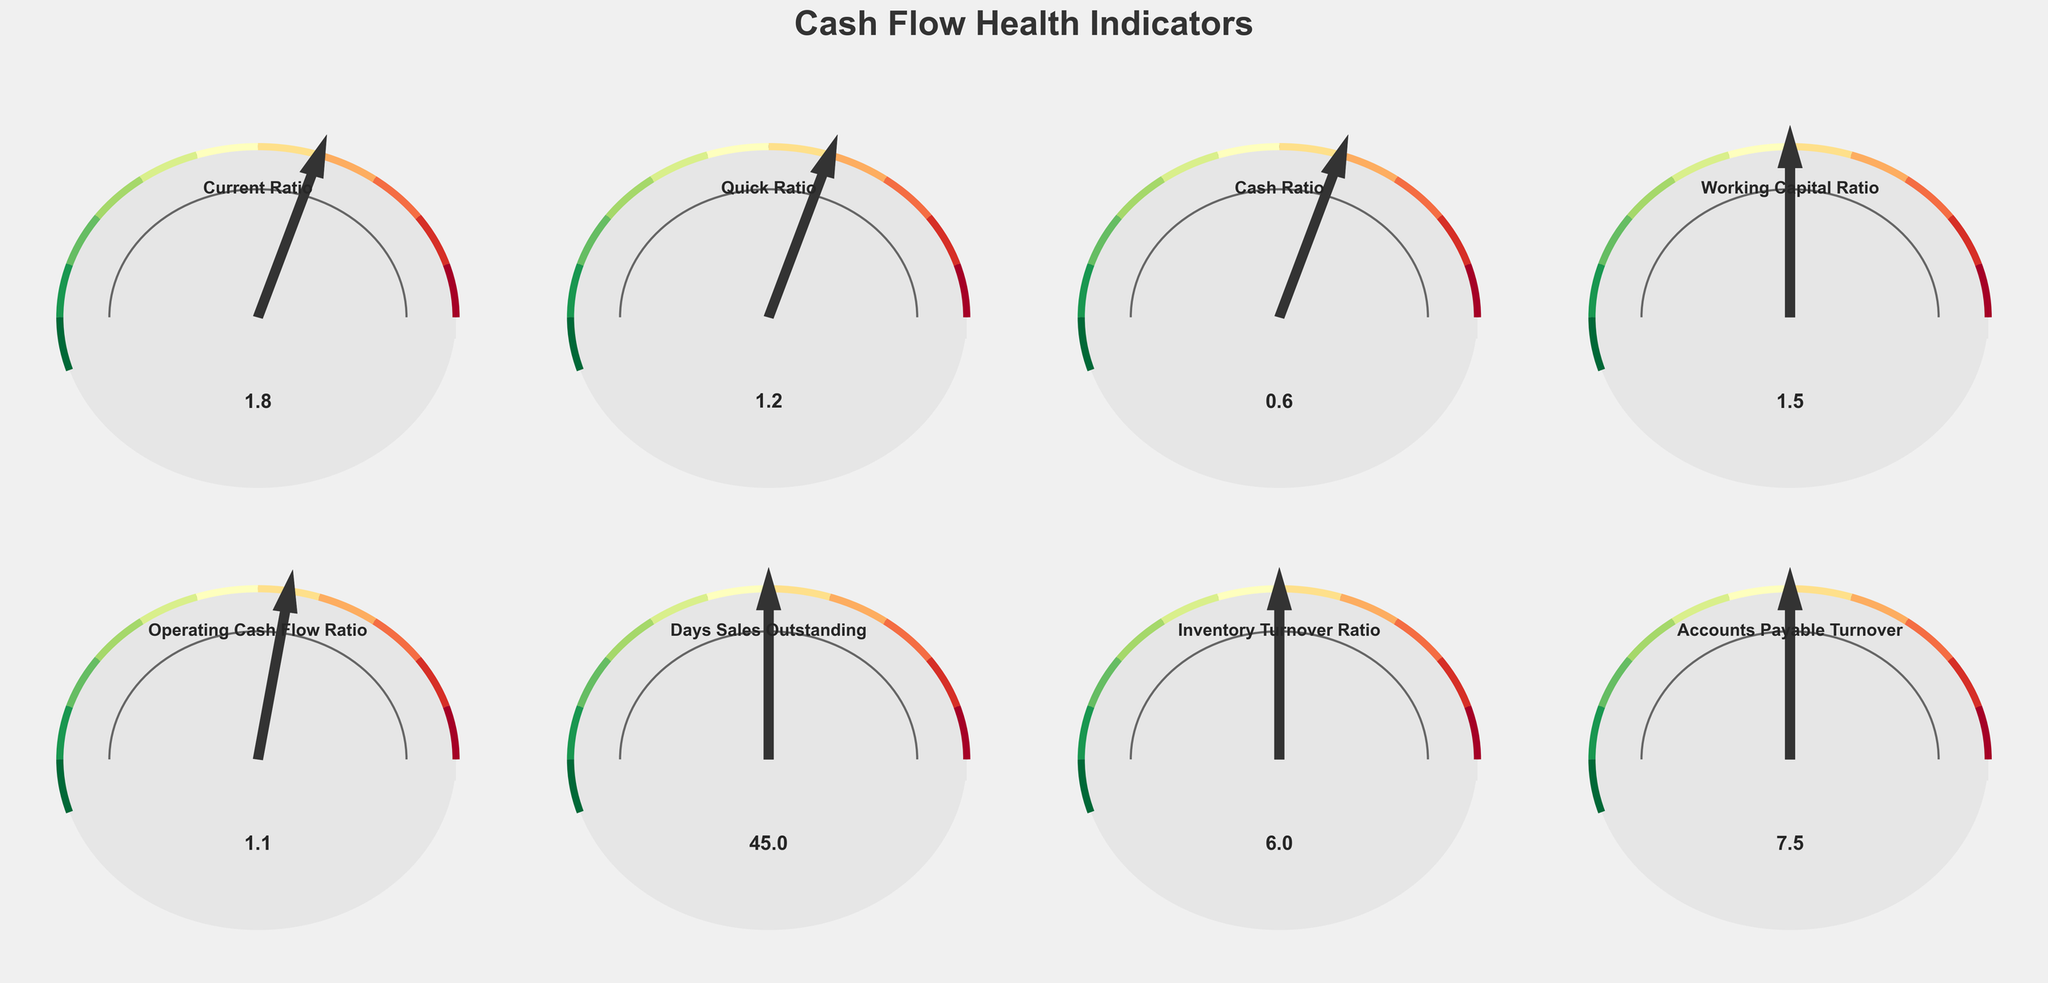What is the value of the Current Ratio? The Current Ratio is displayed on its respective gauge and marked as 1.8.
Answer: 1.8 What is the highest value displayed in any of the gauges? The Days Sales Outstanding gauge shows the highest value, marked at 45 days.
Answer: 45 Which ratio has the smallest range between its minimum and maximum values? The Cash Ratio shows a range from 0 to 1, which is the smallest range compared to other ratios.
Answer: Cash Ratio Among the Operating Cash Flow Ratio and Quick Ratio, which one is closer to the higher end of its range? The Quick Ratio spans from 0 to 2 and is marked at 1.2, while the Operating Cash Flow Ratio spans from 0 to 2 and is marked at 1.1. Therefore, the Quick Ratio is closer to its higher end.
Answer: Quick Ratio Is the Inventory Turnover Ratio within its optimal range according to the visual cues? The optimal range is between 4 and 8, and the Inventory Turnover Ratio is marked at 6, which falls within this range.
Answer: Yes Which metric has its value closest to the mid-point of its respective gauge? The Working Capital Ratio's gauge ranges from 0 to 3, the mid-point is 1.5, and the value is precisely 1.5, making it the closest to the mid-point.
Answer: Working Capital Ratio Are any of the cash flow health indicators below their lower threshold? The Cash Ratio's threshold starts at 0.3, and its value is 0.6, so no indicator is below its lower threshold.
Answer: No What is the difference between the Inventory Turnover Ratio and Accounts Payable Turnover? The Inventory Turnover Ratio is 6, and the Accounts Payable Turnover is 7.5. The difference is 7.5 - 6 = 1.5.
Answer: 1.5 Which indicator shows the greatest deviation from its low threshold? The Days Sales Outstanding has a low threshold of 30 and a value of 45. The deviation is 45 - 30 = 15, which is the greatest among all indicators.
Answer: Days Sales Outstanding 